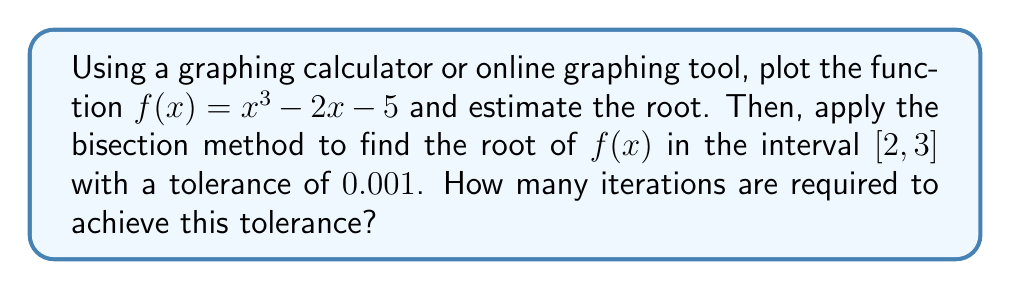Give your solution to this math problem. Let's approach this step-by-step:

1) First, we plot the function $f(x) = x^3 - 2x - 5$ using a graphing tool. We can see that the root lies between 2 and 3.

2) Now, let's apply the bisection method:

   a) Set $a_0 = 2$ and $b_0 = 3$
   b) The tolerance is $\epsilon = 0.001$
   c) We'll stop when $|b_n - a_n| < \epsilon$

3) Iteration 1:
   $c_1 = \frac{a_0 + b_0}{2} = \frac{2 + 3}{2} = 2.5$
   $f(c_1) = (2.5)^3 - 2(2.5) - 5 = 0.625 > 0$
   So, $a_1 = a_0 = 2$, $b_1 = c_1 = 2.5$

4) Iteration 2:
   $c_2 = \frac{2 + 2.5}{2} = 2.25$
   $f(c_2) = (2.25)^3 - 2(2.25) - 5 = -1.859375 < 0$
   So, $a_2 = c_2 = 2.25$, $b_2 = b_1 = 2.5$

5) We continue this process. After each iteration, we check if $|b_n - a_n| < 0.001$

6) After 9 iterations:
   $a_9 = 2.2421875$
   $b_9 = 2.24609375$
   $|b_9 - a_9| = 0.00390625 > 0.001$

7) After 10 iterations:
   $a_{10} = 2.244140625$
   $b_{10} = 2.24609375$
   $|b_{10} - a_{10}| = 0.001953125 > 0.001$

8) After 11 iterations:
   $a_{11} = 2.2451171875$
   $b_{11} = 2.24609375$
   $|b_{11} - a_{11}| = 0.0009765625 < 0.001$

Therefore, it takes 11 iterations to achieve the desired tolerance.
Answer: 11 iterations 